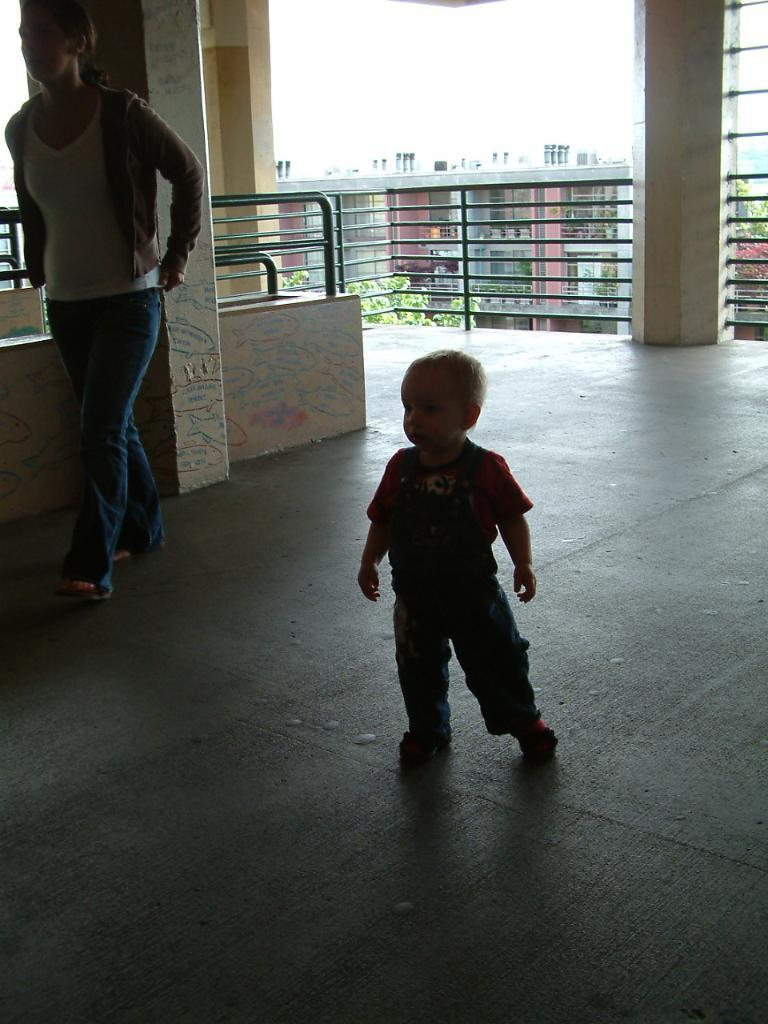Who is present in the image? There is a woman and a boy in the image. What are the woman and boy doing in the image? The woman and boy are walking on the floor in the image. What can be seen in the background of the image? There are trees, a building, and the sky visible in the background of the image. What architectural features are present in the image? There is a wall and railings in the image. What type of lumber is the woman using to sing a song in the image? There is no lumber or singing in the image; the woman and boy are simply walking on the floor. How many books can be seen on the floor in the image? There are no books visible on the floor in the image. 